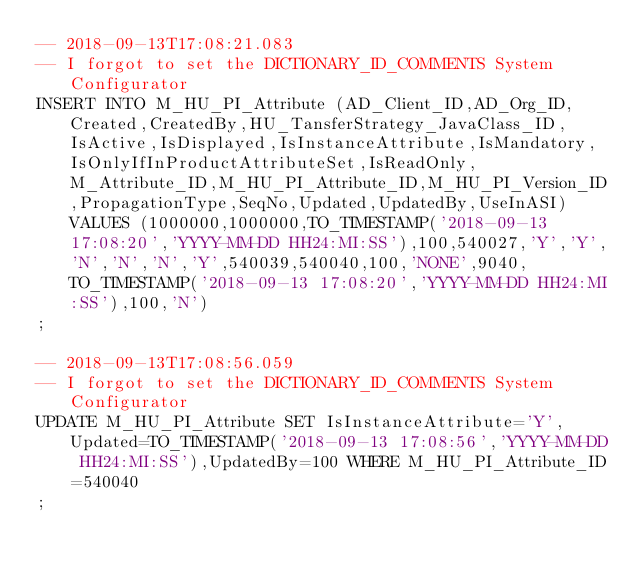Convert code to text. <code><loc_0><loc_0><loc_500><loc_500><_SQL_>-- 2018-09-13T17:08:21.083
-- I forgot to set the DICTIONARY_ID_COMMENTS System Configurator
INSERT INTO M_HU_PI_Attribute (AD_Client_ID,AD_Org_ID,Created,CreatedBy,HU_TansferStrategy_JavaClass_ID,IsActive,IsDisplayed,IsInstanceAttribute,IsMandatory,IsOnlyIfInProductAttributeSet,IsReadOnly,M_Attribute_ID,M_HU_PI_Attribute_ID,M_HU_PI_Version_ID,PropagationType,SeqNo,Updated,UpdatedBy,UseInASI) VALUES (1000000,1000000,TO_TIMESTAMP('2018-09-13 17:08:20','YYYY-MM-DD HH24:MI:SS'),100,540027,'Y','Y','N','N','N','Y',540039,540040,100,'NONE',9040,TO_TIMESTAMP('2018-09-13 17:08:20','YYYY-MM-DD HH24:MI:SS'),100,'N')
;

-- 2018-09-13T17:08:56.059
-- I forgot to set the DICTIONARY_ID_COMMENTS System Configurator
UPDATE M_HU_PI_Attribute SET IsInstanceAttribute='Y',Updated=TO_TIMESTAMP('2018-09-13 17:08:56','YYYY-MM-DD HH24:MI:SS'),UpdatedBy=100 WHERE M_HU_PI_Attribute_ID=540040
;

</code> 